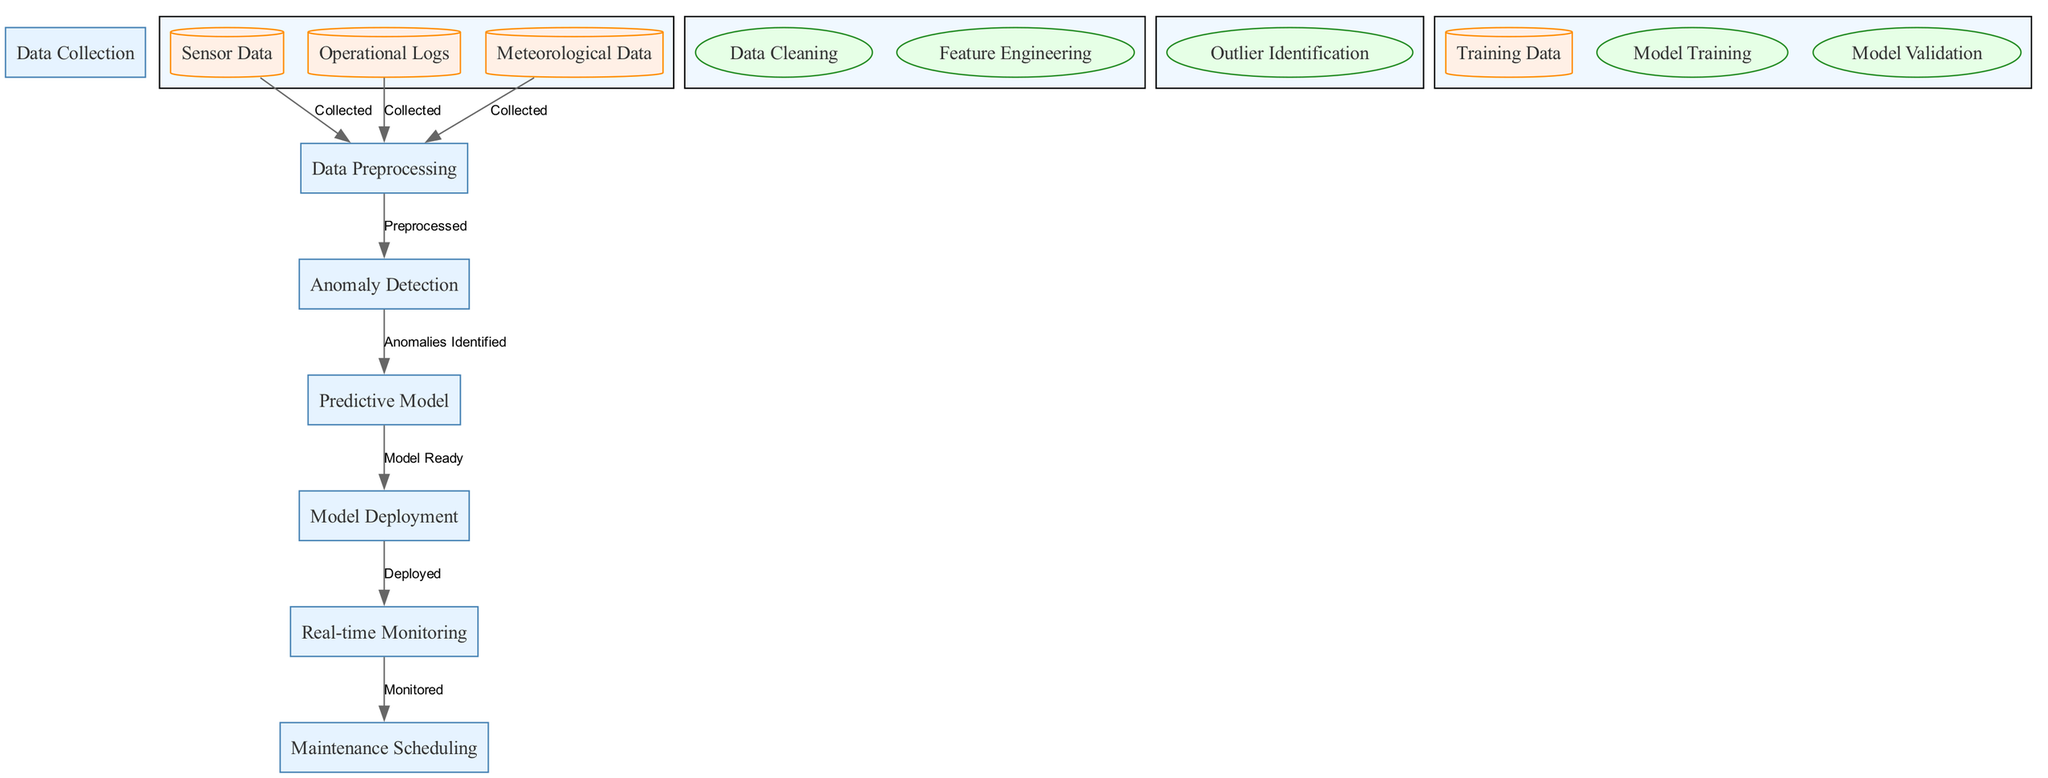What is the first step in the diagram? The first step in the diagram is 'Data Collection', which indicates that the process begins with collecting various types of data before proceeding further.
Answer: Data Collection How many types of data are collected? There are three types of data collected: Sensor Data, Operational Logs, and Meteorological Data. This can be identified by counting the distinct data nodes under the 'Data Collection' process.
Answer: Three What process immediately follows 'Data Preprocessing'? The process that immediately follows 'Data Preprocessing' is 'Anomaly Detection'. This can be determined by looking at the flow of edges from 'Data Preprocessing' to 'Anomaly Detection'.
Answer: Anomaly Detection What task is part of the 'Predictive Model' process? The tasks within the 'Predictive Model' process include 'Model Training' and 'Model Validation', which are specifically labeled as tasks connected to the 'Predictive Model' node.
Answer: Model Training What is the final output of the diagram? The final output of the diagram is 'Maintenance Scheduling', which is the process that takes place after 'Real-time Monitoring', representing the end of the predictive maintenance cycle.
Answer: Maintenance Scheduling Which node collects data specifically from sensors? The node that collects data specifically from sensors is 'Sensor Data', which is a direct data collection identifier under 'Data Collection'.
Answer: Sensor Data What relationship exists between 'Anomaly Detection' and 'Predictive Model'? The relationship is that 'Anomaly Detection' provides identified anomalies, which then feed into the 'Predictive Model'. This is shown by the directed edge connecting the two processes.
Answer: Anomalies Identified How many edges are present in the diagram? There are a total of seven edges present in the diagram, indicating the connections and flow between various processes and data points. This can be verified by counting the lines connecting the nodes.
Answer: Seven Which process is characterized by 'Deployed'? The process characterized by 'Deployed' is 'Model Deployment', indicating that the predictive model is put into active use after it is ready. This can be identified by locating the label on the edge connecting 'Predictive Model' to 'Model Deployment'.
Answer: Model Deployment 